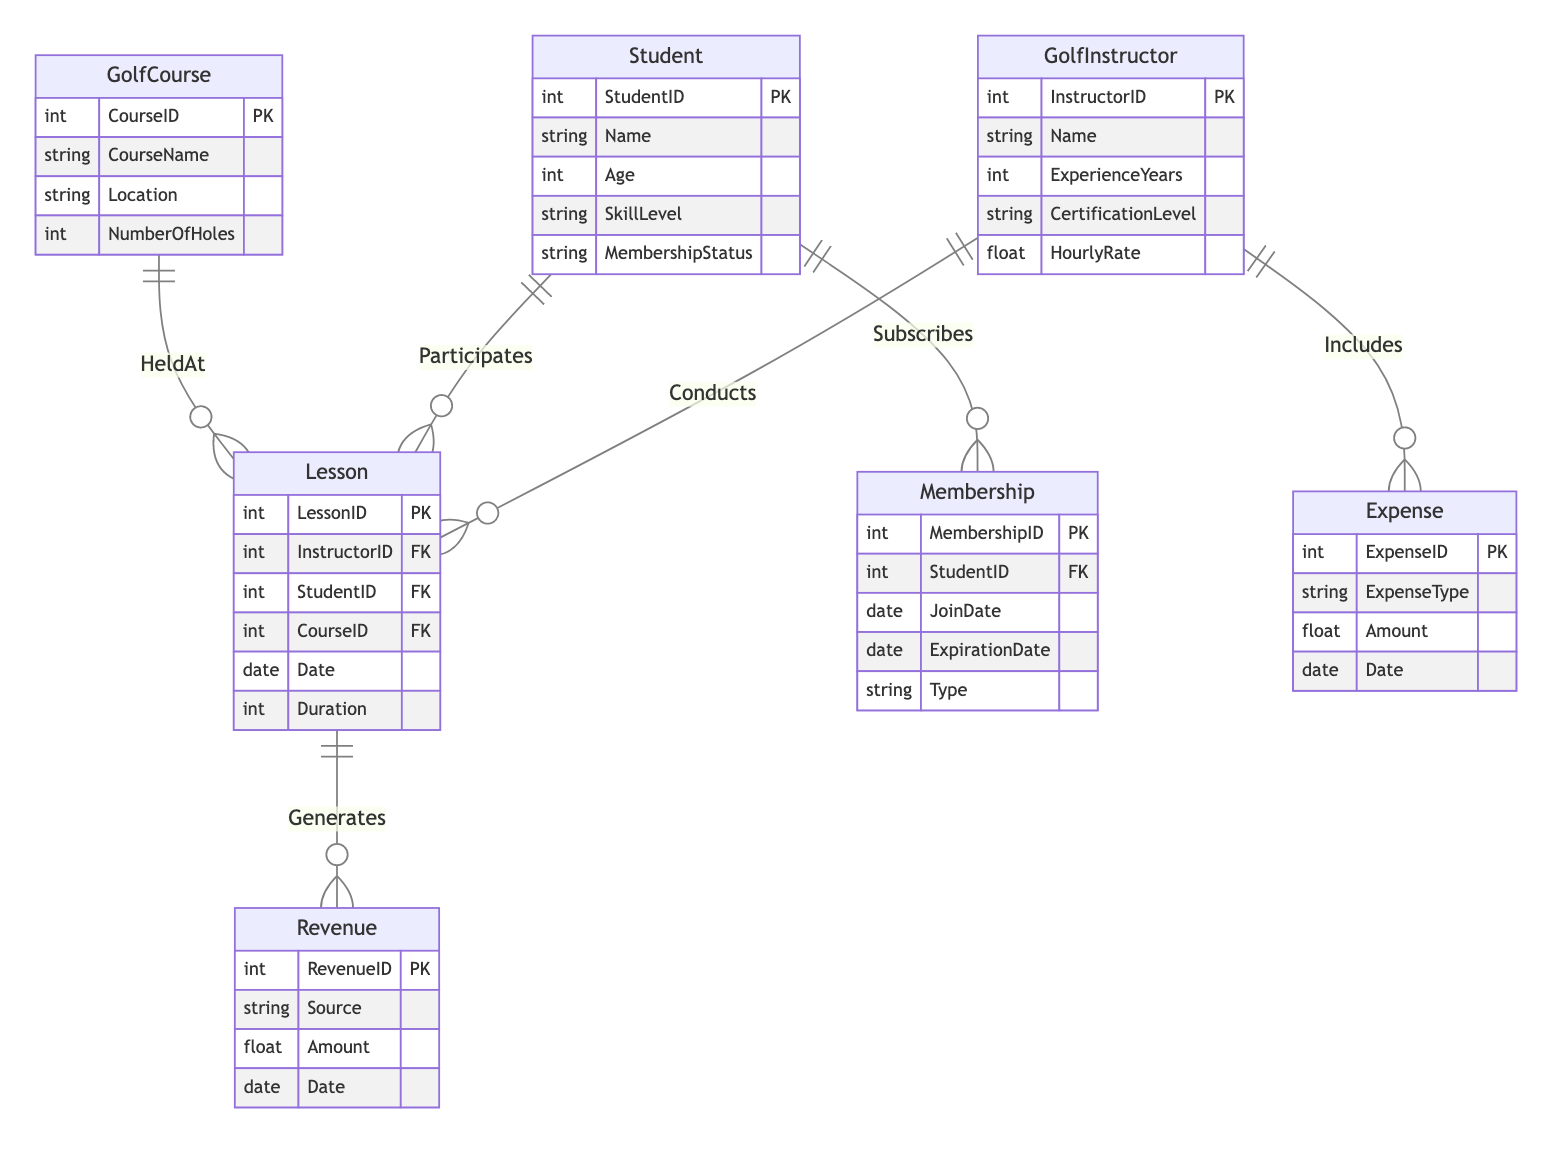What is the primary entity for conducting lessons? The diagram shows that the "GolfInstructor" entity is connected to the "Lesson" entity through the "Conducts" relationship, indicating that golf instructors conduct lessons.
Answer: GolfInstructor How many entities are in the diagram? By counting the listed entities, we find there are a total of 7 entities: GolfInstructor, Student, GolfCourse, Lesson, Membership, Revenue, and Expense.
Answer: 7 What is the relationship type between Student and Membership? The diagram outlines that the "Subscribes" relationship connects the "Student" entity with the "Membership" entity, indicating how students subscribe to memberships.
Answer: Subscribes Which entity generates revenue from lessons? The diagram shows that the "Lesson" entity is associated with the "Revenue" entity through the "Generates" relationship, meaning lessons generate revenue.
Answer: Lesson What attribute links the Lesson to the Instructor? The "InstructorID" attribute is indicated in the "Lesson" entity and is also mentioned in the relationship "Conducts" with "GolfInstructor", linking the two entities.
Answer: InstructorID How many relationships are depicted in the diagram? Upon reviewing the relationships listed in the diagram, we can see that there are 6 relationships connecting the entities.
Answer: 6 What does the Expense entity include? The "Includes" relationship between the "GolfInstructor" and the "Expense" entities implies that various expenses are accounted for within the context of golf instructors.
Answer: Expense What is the primary purpose of the Membership entity? The "Membership" entity allows tracking of students who join and maintain memberships in the golf instruction services, which is its primary purpose.
Answer: Membership Which entity holds lessons at golf courses? The "HeldAt" relationship shows that the "Lesson" entity is linked to the "GolfCourse" entity, indicating that lessons are held at golf courses.
Answer: GolfCourse 